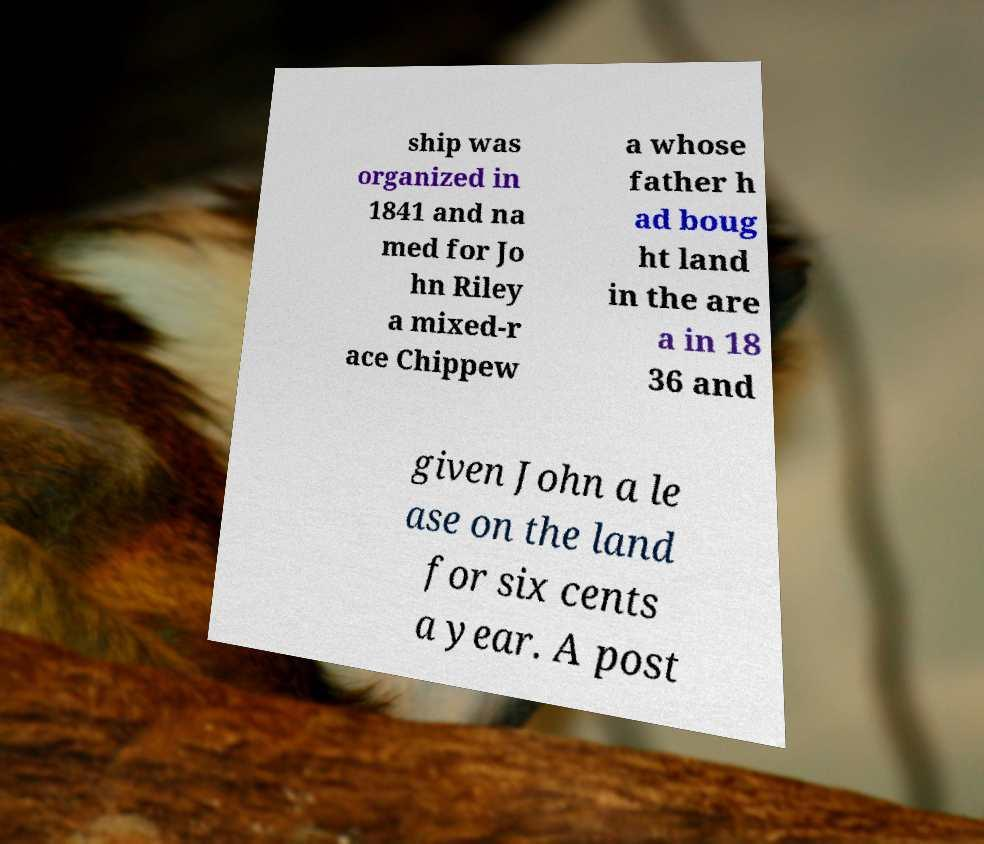Please read and relay the text visible in this image. What does it say? ship was organized in 1841 and na med for Jo hn Riley a mixed-r ace Chippew a whose father h ad boug ht land in the are a in 18 36 and given John a le ase on the land for six cents a year. A post 